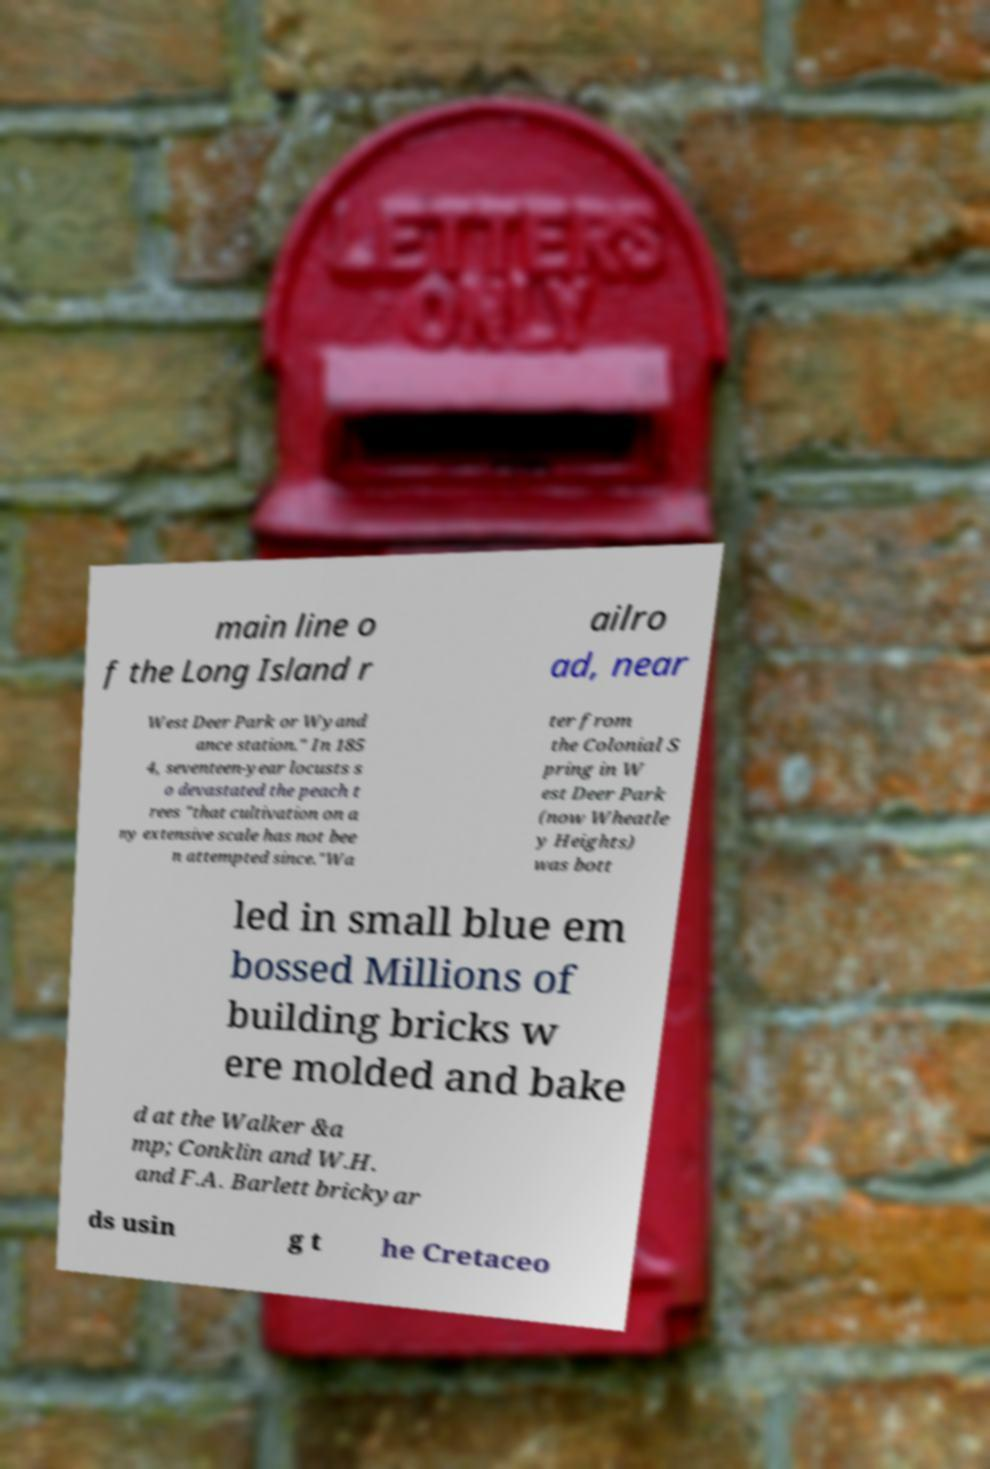Please identify and transcribe the text found in this image. main line o f the Long Island r ailro ad, near West Deer Park or Wyand ance station." In 185 4, seventeen-year locusts s o devastated the peach t rees "that cultivation on a ny extensive scale has not bee n attempted since."Wa ter from the Colonial S pring in W est Deer Park (now Wheatle y Heights) was bott led in small blue em bossed Millions of building bricks w ere molded and bake d at the Walker &a mp; Conklin and W.H. and F.A. Barlett brickyar ds usin g t he Cretaceo 